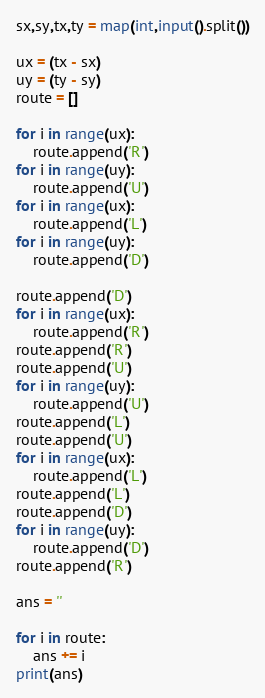<code> <loc_0><loc_0><loc_500><loc_500><_Python_>sx,sy,tx,ty = map(int,input().split())

ux = (tx - sx)
uy = (ty - sy)
route = []

for i in range(ux):
    route.append('R')
for i in range(uy):
    route.append('U')
for i in range(ux):
    route.append('L')
for i in range(uy):
    route.append('D')
    
route.append('D')
for i in range(ux):
    route.append('R')
route.append('R')
route.append('U')
for i in range(uy):
    route.append('U')
route.append('L')
route.append('U')
for i in range(ux):
    route.append('L')
route.append('L')
route.append('D')
for i in range(uy):
    route.append('D')
route.append('R')

ans = ''

for i in route:
    ans += i
print(ans)</code> 